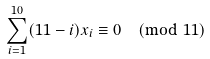<formula> <loc_0><loc_0><loc_500><loc_500>\sum _ { i = 1 } ^ { 1 0 } ( 1 1 - i ) x _ { i } \equiv 0 { \pmod { 1 1 } }</formula> 